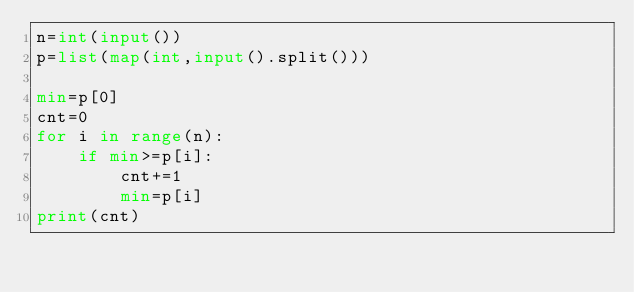Convert code to text. <code><loc_0><loc_0><loc_500><loc_500><_Python_>n=int(input())
p=list(map(int,input().split()))

min=p[0]
cnt=0
for i in range(n):
    if min>=p[i]:
        cnt+=1
        min=p[i]
print(cnt)
</code> 